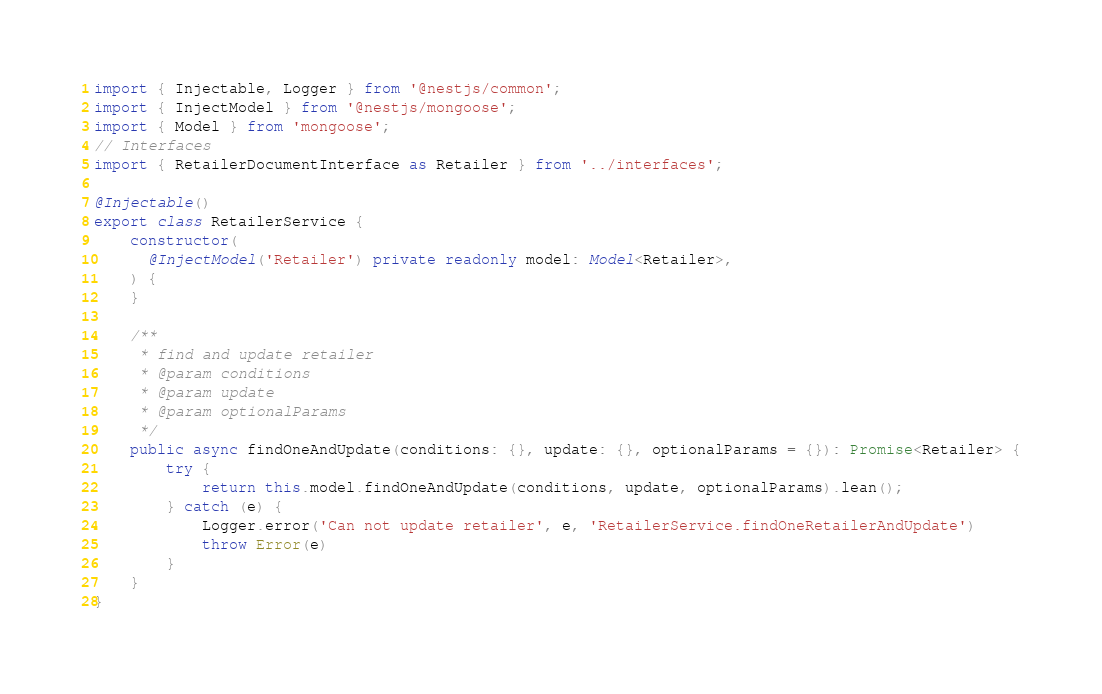<code> <loc_0><loc_0><loc_500><loc_500><_TypeScript_>import { Injectable, Logger } from '@nestjs/common';
import { InjectModel } from '@nestjs/mongoose';
import { Model } from 'mongoose';
// Interfaces
import { RetailerDocumentInterface as Retailer } from '../interfaces';

@Injectable()
export class RetailerService {
    constructor(
      @InjectModel('Retailer') private readonly model: Model<Retailer>,
    ) {
    }

    /**
     * find and update retailer
     * @param conditions
     * @param update
     * @param optionalParams
     */
    public async findOneAndUpdate(conditions: {}, update: {}, optionalParams = {}): Promise<Retailer> {
        try {
            return this.model.findOneAndUpdate(conditions, update, optionalParams).lean();
        } catch (e) {
            Logger.error('Can not update retailer', e, 'RetailerService.findOneRetailerAndUpdate')
            throw Error(e)
        }
    }
}
</code> 